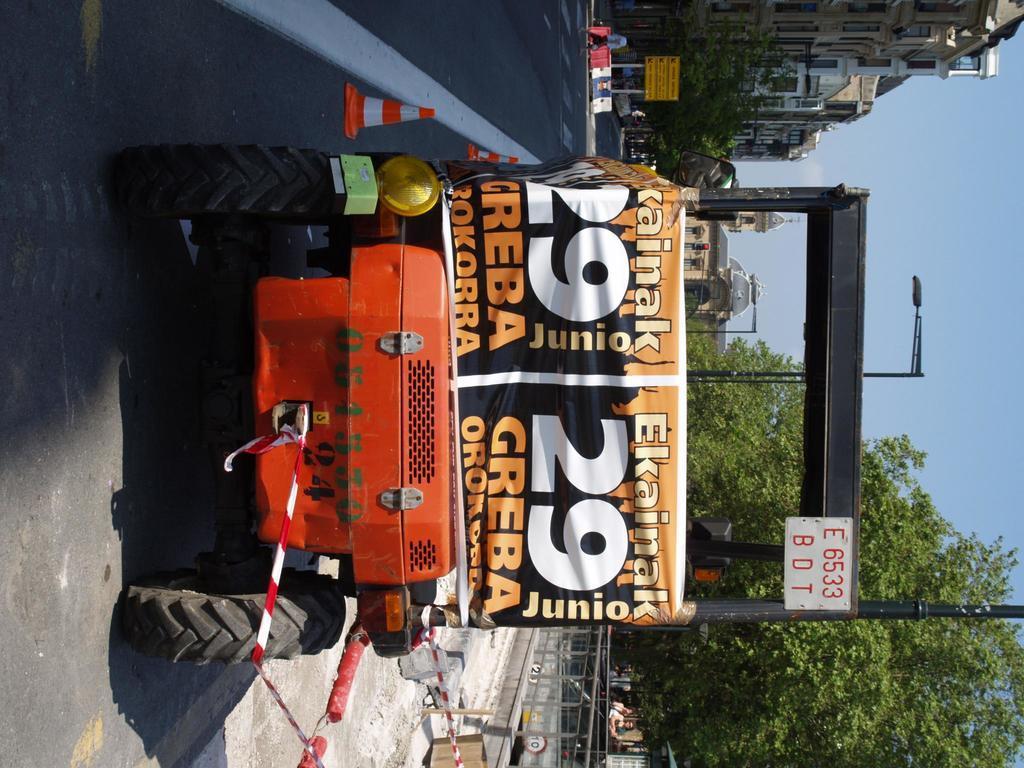Describe this image in one or two sentences. In this picture we can see a vehicle in the front, in the background there are some buildings, trees, poles, lights, a board and a person, at the bottom there are some barricades, we can see the sky on the right side, there are two traffic cones here. 